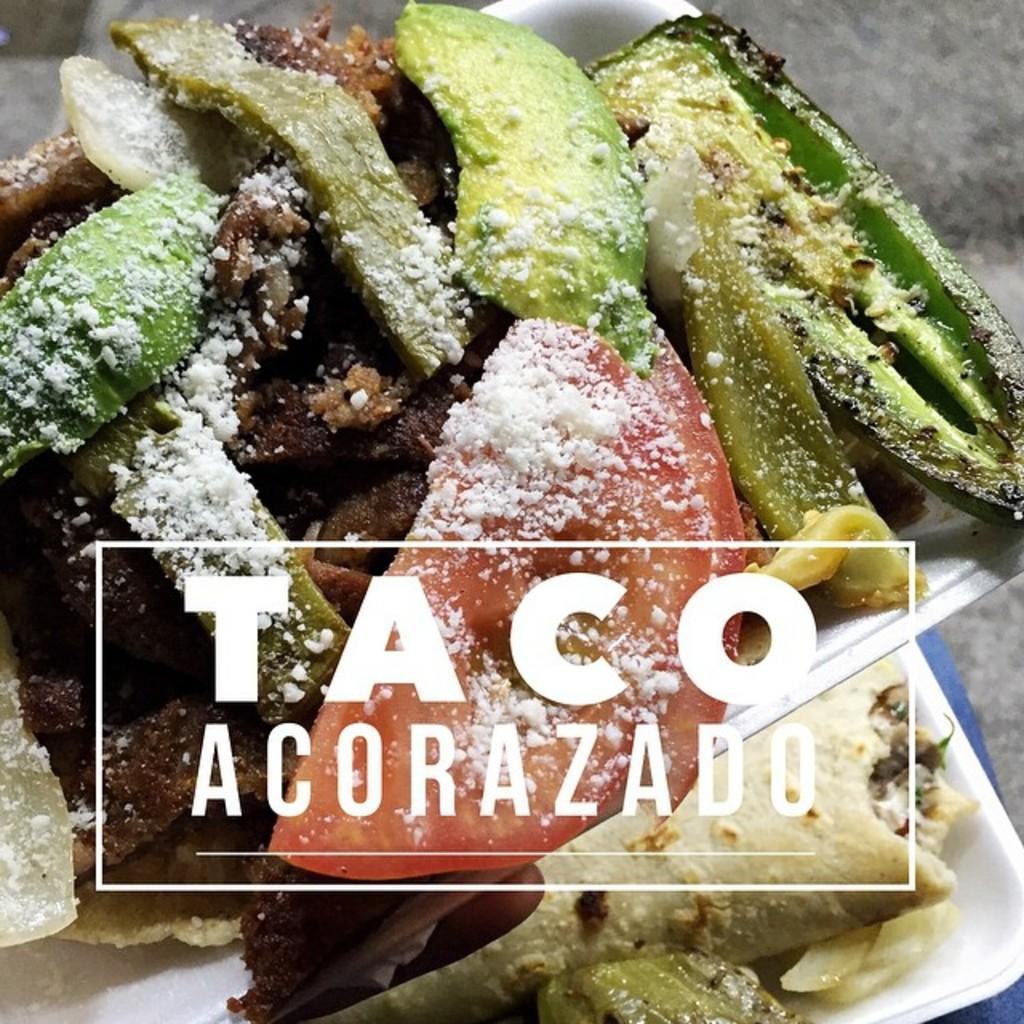What is present on the tray in the image? There are food items on a tray in the image. Can you describe any text or writing in the image? Yes, there is writing on the image. How many giraffes can be seen in the image? There are no giraffes present in the image. What type of fuel is being used by the snakes in the image? There are no snakes or fuel present in the image. 